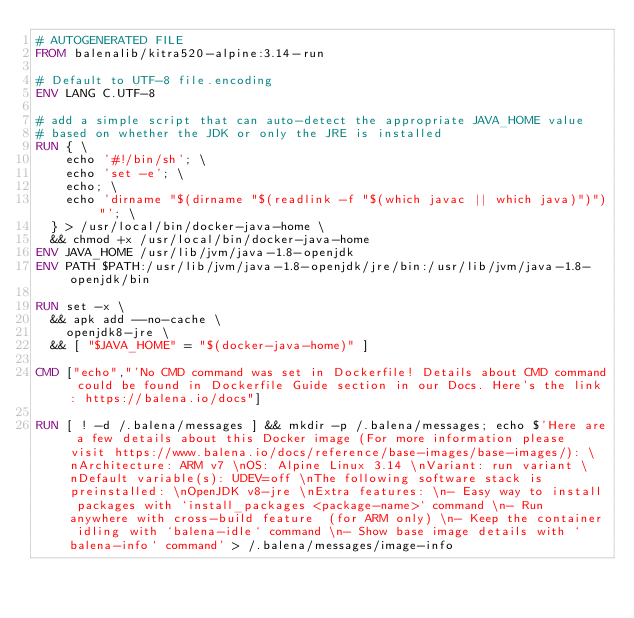<code> <loc_0><loc_0><loc_500><loc_500><_Dockerfile_># AUTOGENERATED FILE
FROM balenalib/kitra520-alpine:3.14-run

# Default to UTF-8 file.encoding
ENV LANG C.UTF-8

# add a simple script that can auto-detect the appropriate JAVA_HOME value
# based on whether the JDK or only the JRE is installed
RUN { \
		echo '#!/bin/sh'; \
		echo 'set -e'; \
		echo; \
		echo 'dirname "$(dirname "$(readlink -f "$(which javac || which java)")")"'; \
	} > /usr/local/bin/docker-java-home \
	&& chmod +x /usr/local/bin/docker-java-home
ENV JAVA_HOME /usr/lib/jvm/java-1.8-openjdk
ENV PATH $PATH:/usr/lib/jvm/java-1.8-openjdk/jre/bin:/usr/lib/jvm/java-1.8-openjdk/bin

RUN set -x \
	&& apk add --no-cache \
		openjdk8-jre \
	&& [ "$JAVA_HOME" = "$(docker-java-home)" ]

CMD ["echo","'No CMD command was set in Dockerfile! Details about CMD command could be found in Dockerfile Guide section in our Docs. Here's the link: https://balena.io/docs"]

RUN [ ! -d /.balena/messages ] && mkdir -p /.balena/messages; echo $'Here are a few details about this Docker image (For more information please visit https://www.balena.io/docs/reference/base-images/base-images/): \nArchitecture: ARM v7 \nOS: Alpine Linux 3.14 \nVariant: run variant \nDefault variable(s): UDEV=off \nThe following software stack is preinstalled: \nOpenJDK v8-jre \nExtra features: \n- Easy way to install packages with `install_packages <package-name>` command \n- Run anywhere with cross-build feature  (for ARM only) \n- Keep the container idling with `balena-idle` command \n- Show base image details with `balena-info` command' > /.balena/messages/image-info</code> 